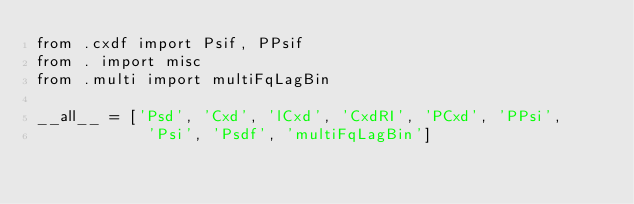<code> <loc_0><loc_0><loc_500><loc_500><_Python_>from .cxdf import Psif, PPsif
from . import misc
from .multi import multiFqLagBin

__all__ = ['Psd', 'Cxd', 'lCxd', 'CxdRI', 'PCxd', 'PPsi', 
            'Psi', 'Psdf', 'multiFqLagBin']</code> 